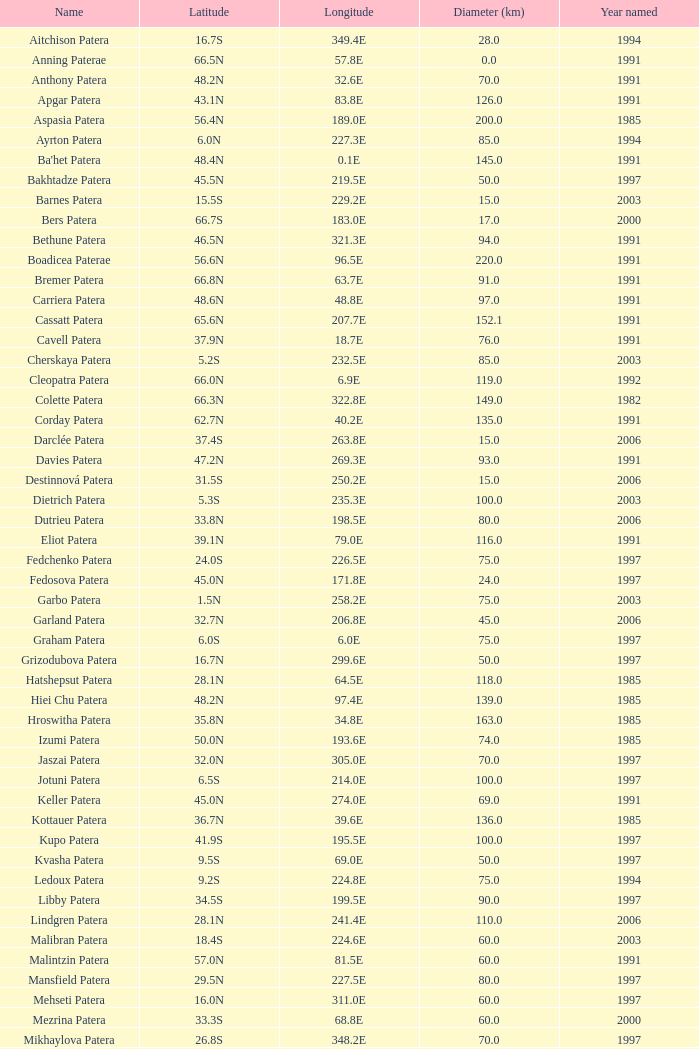What is the designated year when the longitude is 22 1997.0. 